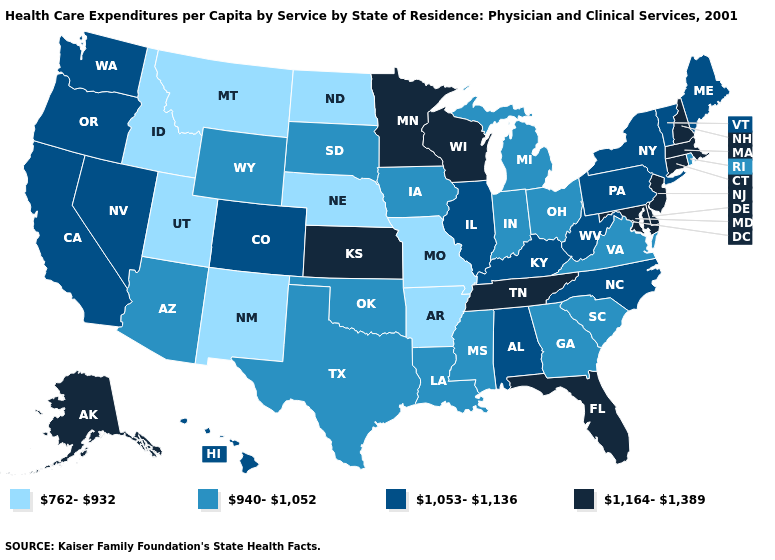Name the states that have a value in the range 1,053-1,136?
Give a very brief answer. Alabama, California, Colorado, Hawaii, Illinois, Kentucky, Maine, Nevada, New York, North Carolina, Oregon, Pennsylvania, Vermont, Washington, West Virginia. Which states hav the highest value in the MidWest?
Be succinct. Kansas, Minnesota, Wisconsin. What is the value of Wyoming?
Write a very short answer. 940-1,052. Does New Mexico have the same value as Nebraska?
Quick response, please. Yes. What is the lowest value in the USA?
Concise answer only. 762-932. Among the states that border California , which have the lowest value?
Write a very short answer. Arizona. Among the states that border Ohio , does Pennsylvania have the lowest value?
Quick response, please. No. Does the first symbol in the legend represent the smallest category?
Quick response, please. Yes. Name the states that have a value in the range 1,164-1,389?
Give a very brief answer. Alaska, Connecticut, Delaware, Florida, Kansas, Maryland, Massachusetts, Minnesota, New Hampshire, New Jersey, Tennessee, Wisconsin. What is the value of Montana?
Quick response, please. 762-932. What is the lowest value in the Northeast?
Quick response, please. 940-1,052. What is the value of Vermont?
Quick response, please. 1,053-1,136. Does North Dakota have the lowest value in the USA?
Keep it brief. Yes. How many symbols are there in the legend?
Give a very brief answer. 4. What is the highest value in the USA?
Write a very short answer. 1,164-1,389. 